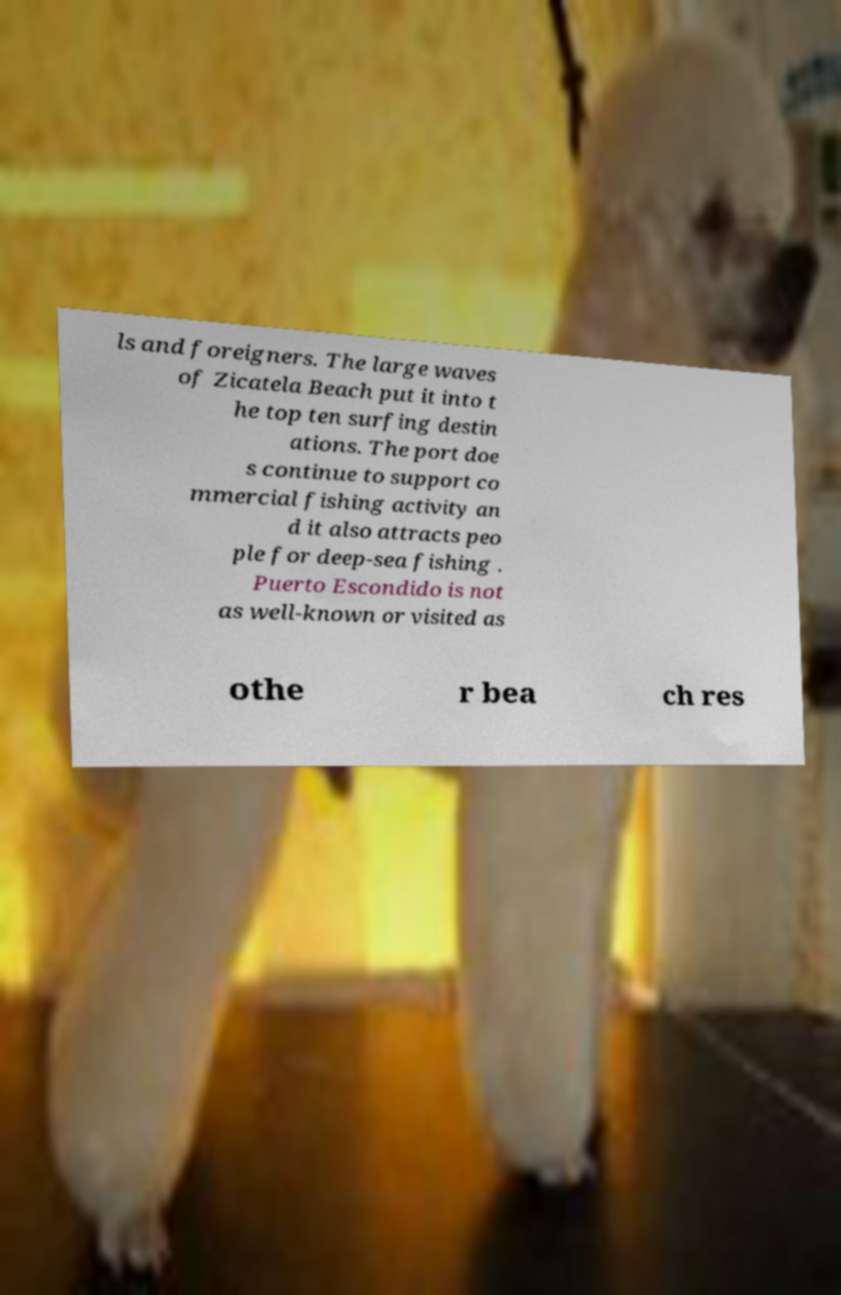Please read and relay the text visible in this image. What does it say? ls and foreigners. The large waves of Zicatela Beach put it into t he top ten surfing destin ations. The port doe s continue to support co mmercial fishing activity an d it also attracts peo ple for deep-sea fishing . Puerto Escondido is not as well-known or visited as othe r bea ch res 